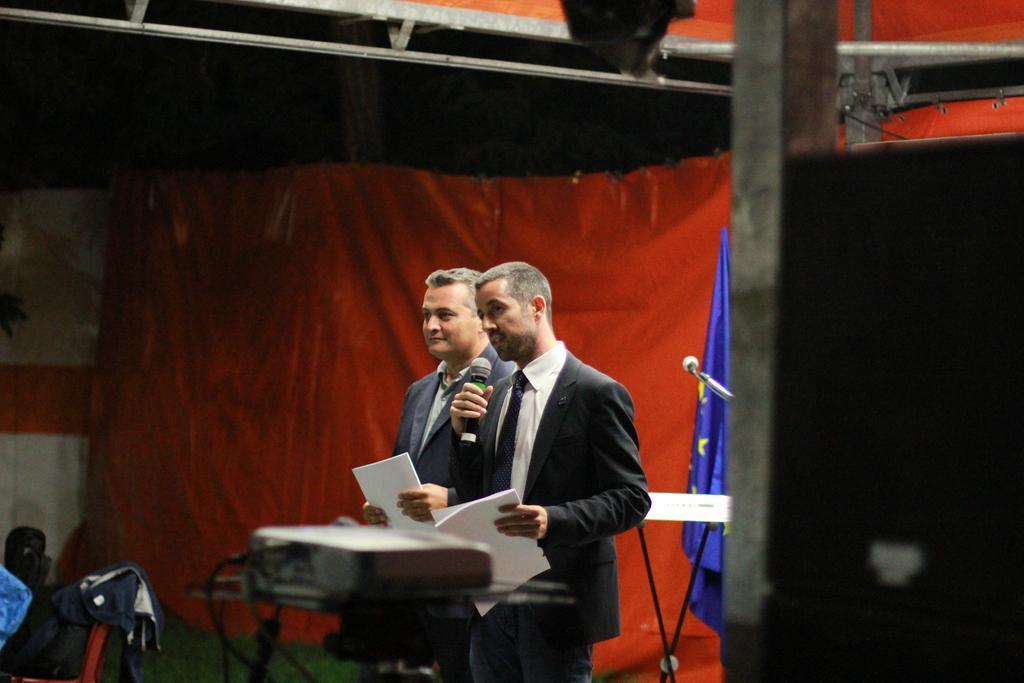How would you summarize this image in a sentence or two? In this image we can see few people. A person is sitting at the left side of the image. There is a flag and a table at the right side of the image. There is a projector in the image. There are few objects in the image. There is a curtain in the image. 